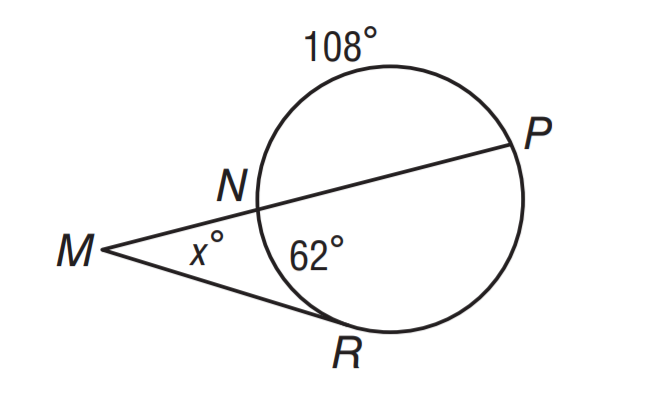What is the value of x if m \widehat N R = 62 and m \widehat N P = 108? To find the value of x, we can use the fact that the angles around point N inside the triangle must sum up to 180 degrees, since it is on a straight line. Given m \widehat N R = 62 degrees and m \widehat N P = 108 degrees, we add these two angles together to get 170 degrees. Subtracting this from 180 degrees, we find that the angle represented by x must be 180 - 170 = 10 degrees. Therefore, none of the choices A: 23, B: 31, C: 64, or D: 128 are correct; the value of x should actually be 10 degrees, which is not listed in the provided choices. 